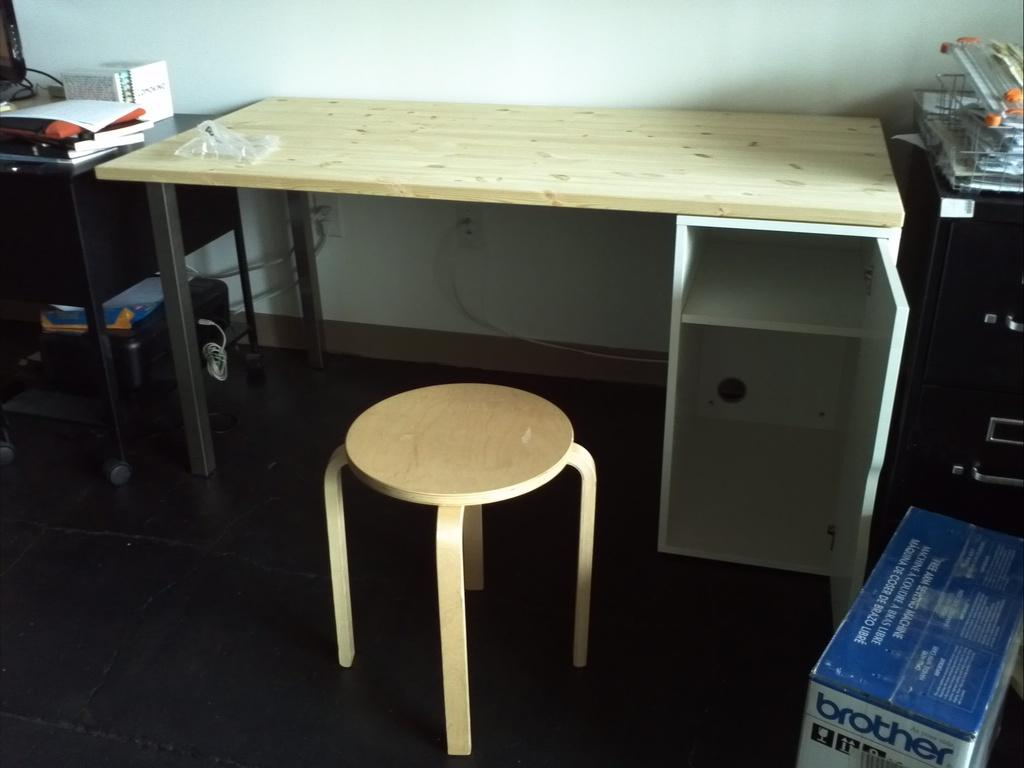<image>
Create a compact narrative representing the image presented. An empty desk with a stool at it and a brother box on the floor. 